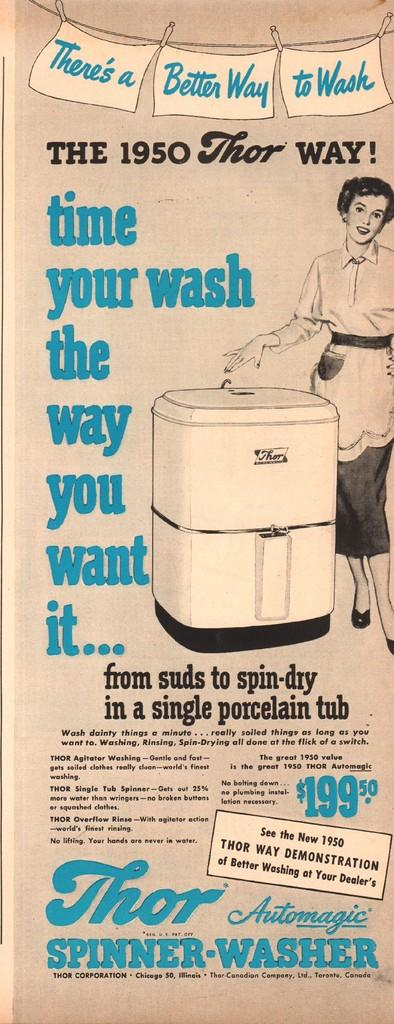<image>
Share a concise interpretation of the image provided. A piece of paper says There's a Better Way to Wash. 